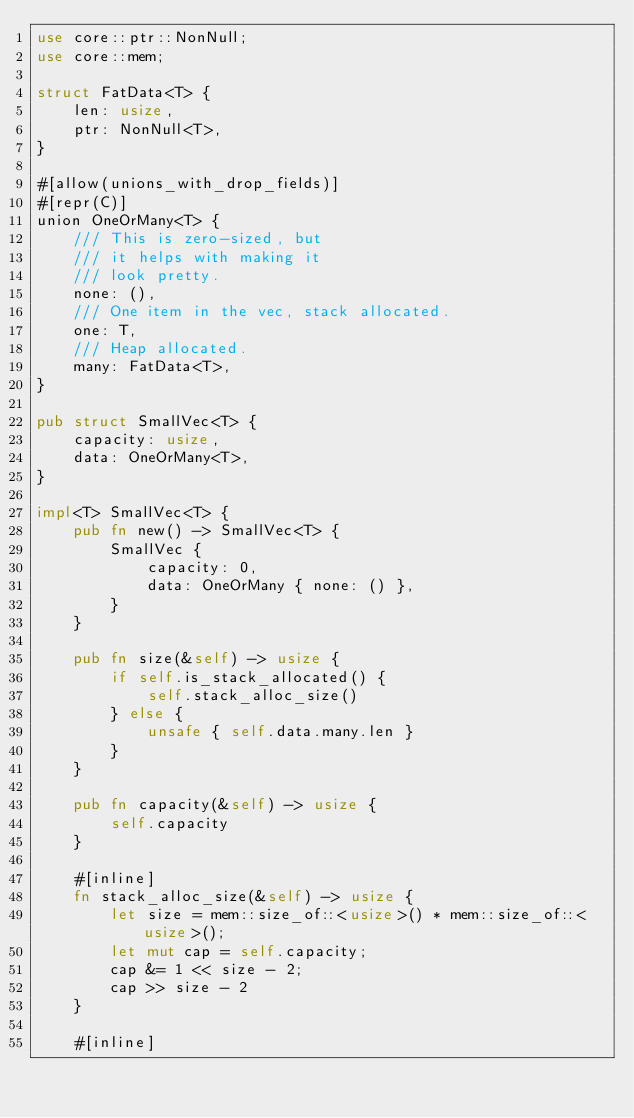Convert code to text. <code><loc_0><loc_0><loc_500><loc_500><_Rust_>use core::ptr::NonNull;
use core::mem;

struct FatData<T> {
    len: usize,
    ptr: NonNull<T>,
}

#[allow(unions_with_drop_fields)]
#[repr(C)]
union OneOrMany<T> {
    /// This is zero-sized, but
    /// it helps with making it
    /// look pretty.
    none: (),
    /// One item in the vec, stack allocated.
    one: T,
    /// Heap allocated.
    many: FatData<T>,
}

pub struct SmallVec<T> {
    capacity: usize,
    data: OneOrMany<T>,
}

impl<T> SmallVec<T> {
    pub fn new() -> SmallVec<T> {
        SmallVec {
            capacity: 0,
            data: OneOrMany { none: () },
        }
    }

    pub fn size(&self) -> usize {
        if self.is_stack_allocated() {
            self.stack_alloc_size()
        } else {
            unsafe { self.data.many.len }
        }
    }

    pub fn capacity(&self) -> usize {
        self.capacity
    }

    #[inline]
    fn stack_alloc_size(&self) -> usize {
        let size = mem::size_of::<usize>() * mem::size_of::<usize>();
        let mut cap = self.capacity;
        cap &= 1 << size - 2;
        cap >> size - 2
    }

    #[inline]</code> 